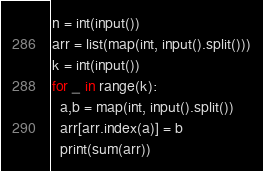Convert code to text. <code><loc_0><loc_0><loc_500><loc_500><_Python_>n = int(input())
arr = list(map(int, input().split()))
k = int(input())
for _ in range(k):
  a,b = map(int, input().split())
  arr[arr.index(a)] = b
  print(sum(arr))</code> 